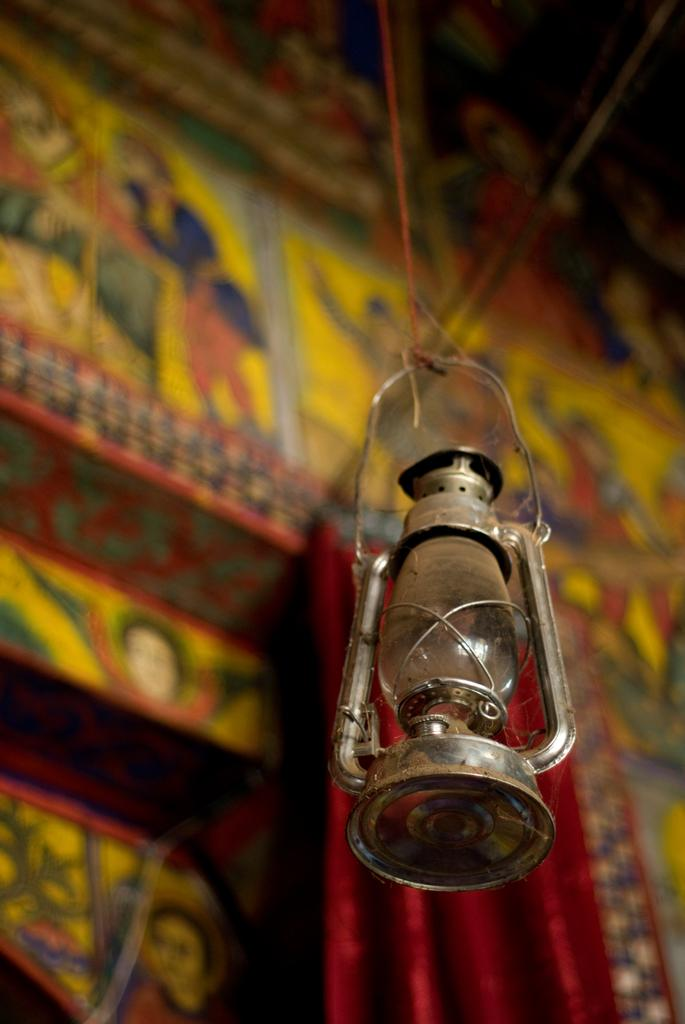What is the main object in the front of the image? There is a lantern lamp in the front of the image. How would you describe the background of the image? The background of the image is blurred. Can you describe any specific features of the background? There is a designed wall in the background of the image. How many chickens can be seen on the roof in the image? There are no chickens or roof present in the image. 